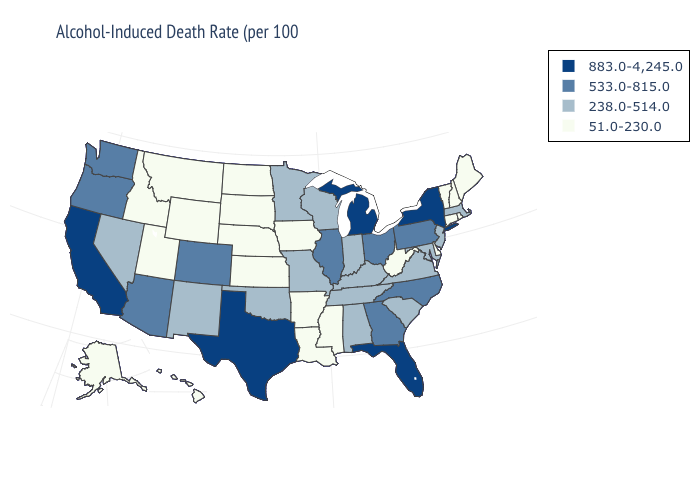What is the highest value in states that border Delaware?
Quick response, please. 533.0-815.0. Name the states that have a value in the range 883.0-4,245.0?
Keep it brief. California, Florida, Michigan, New York, Texas. Does Delaware have a lower value than Rhode Island?
Be succinct. No. Which states hav the highest value in the Northeast?
Concise answer only. New York. Name the states that have a value in the range 883.0-4,245.0?
Keep it brief. California, Florida, Michigan, New York, Texas. Does Nebraska have the lowest value in the USA?
Give a very brief answer. Yes. Among the states that border Nevada , does California have the highest value?
Quick response, please. Yes. Which states have the lowest value in the USA?
Be succinct. Alaska, Arkansas, Connecticut, Delaware, Hawaii, Idaho, Iowa, Kansas, Louisiana, Maine, Mississippi, Montana, Nebraska, New Hampshire, North Dakota, Rhode Island, South Dakota, Utah, Vermont, West Virginia, Wyoming. Name the states that have a value in the range 238.0-514.0?
Answer briefly. Alabama, Indiana, Kentucky, Maryland, Massachusetts, Minnesota, Missouri, Nevada, New Jersey, New Mexico, Oklahoma, South Carolina, Tennessee, Virginia, Wisconsin. What is the value of Hawaii?
Short answer required. 51.0-230.0. Among the states that border Illinois , which have the lowest value?
Keep it brief. Iowa. Name the states that have a value in the range 51.0-230.0?
Be succinct. Alaska, Arkansas, Connecticut, Delaware, Hawaii, Idaho, Iowa, Kansas, Louisiana, Maine, Mississippi, Montana, Nebraska, New Hampshire, North Dakota, Rhode Island, South Dakota, Utah, Vermont, West Virginia, Wyoming. Does New Mexico have the same value as Arizona?
Give a very brief answer. No. Among the states that border Rhode Island , does Connecticut have the highest value?
Keep it brief. No. Among the states that border Tennessee , which have the highest value?
Write a very short answer. Georgia, North Carolina. 